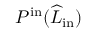Convert formula to latex. <formula><loc_0><loc_0><loc_500><loc_500>P ^ { i n } ( \widehat { L } _ { i n } )</formula> 